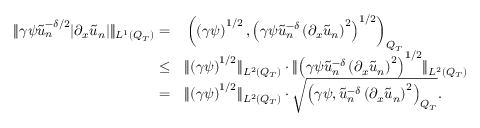Convert formula to latex. <formula><loc_0><loc_0><loc_500><loc_500>\begin{array} { r l } { \| \gamma \psi \tilde { u } _ { n } ^ { - \delta / 2 } | \partial _ { x } \tilde { u } _ { n } | \| _ { L ^ { 1 } ( Q _ { T } ) } = } & \left ( \left ( \gamma \psi \right ) ^ { 1 / 2 } , \left ( \gamma \psi \tilde { u } _ { n } ^ { - \delta } \left ( \partial _ { x } \tilde { u } _ { n } \right ) ^ { 2 } \right ) ^ { 1 / 2 } \right ) _ { Q _ { T } } } \\ { \leq } & \| \left ( \gamma \psi \right ) ^ { 1 / 2 } \| _ { L ^ { 2 } ( Q _ { T } ) } \cdot \| \left ( \gamma \psi \tilde { u } _ { n } ^ { - \delta } \left ( \partial _ { x } \tilde { u } _ { n } \right ) ^ { 2 } \right ) ^ { 1 / 2 } \| _ { L ^ { 2 } ( Q _ { T } ) } } \\ { = } & \| \left ( \gamma \psi \right ) ^ { 1 / 2 } \| _ { L ^ { 2 } ( Q _ { T } ) } \cdot \sqrt { \left ( \gamma \psi , \tilde { u } _ { n } ^ { - \delta } \left ( \partial _ { x } \tilde { u } _ { n } \right ) ^ { 2 } \right ) _ { Q _ { T } } } . } \end{array}</formula> 